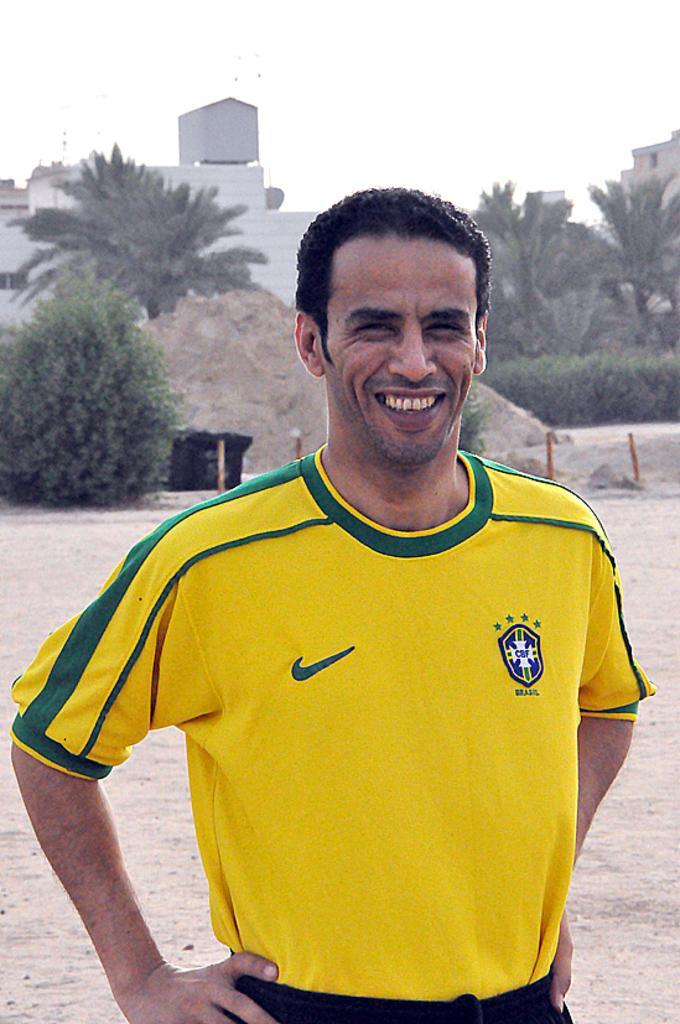How would you summarize this image in a sentence or two? In the image there is a man wearing a yellow color shirt is standing and he is also having smile on his face. In background we can see some plants,trees,buildings,sand and sky is on top. 